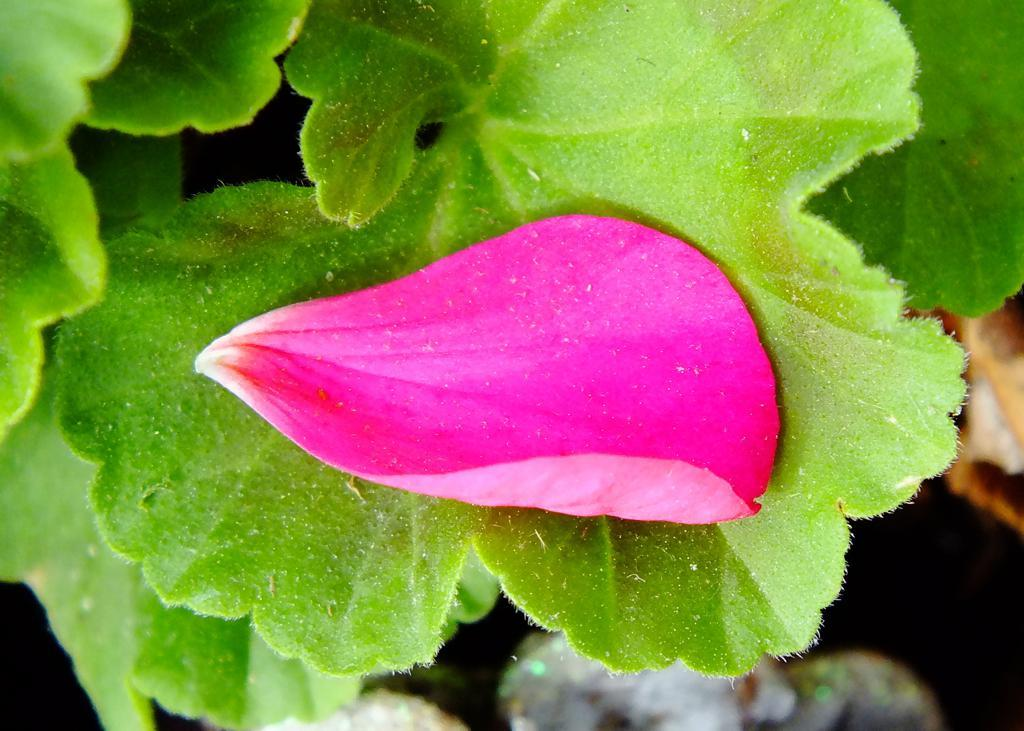What is the main subject in the center of the image? There is a flower petal in the center of the image. What other parts of the plant can be seen in the image? There are leaves in the image. How many copies of the tray are visible in the image? There is no tray present in the image. What type of man can be seen in the image? There is no man present in the image. 